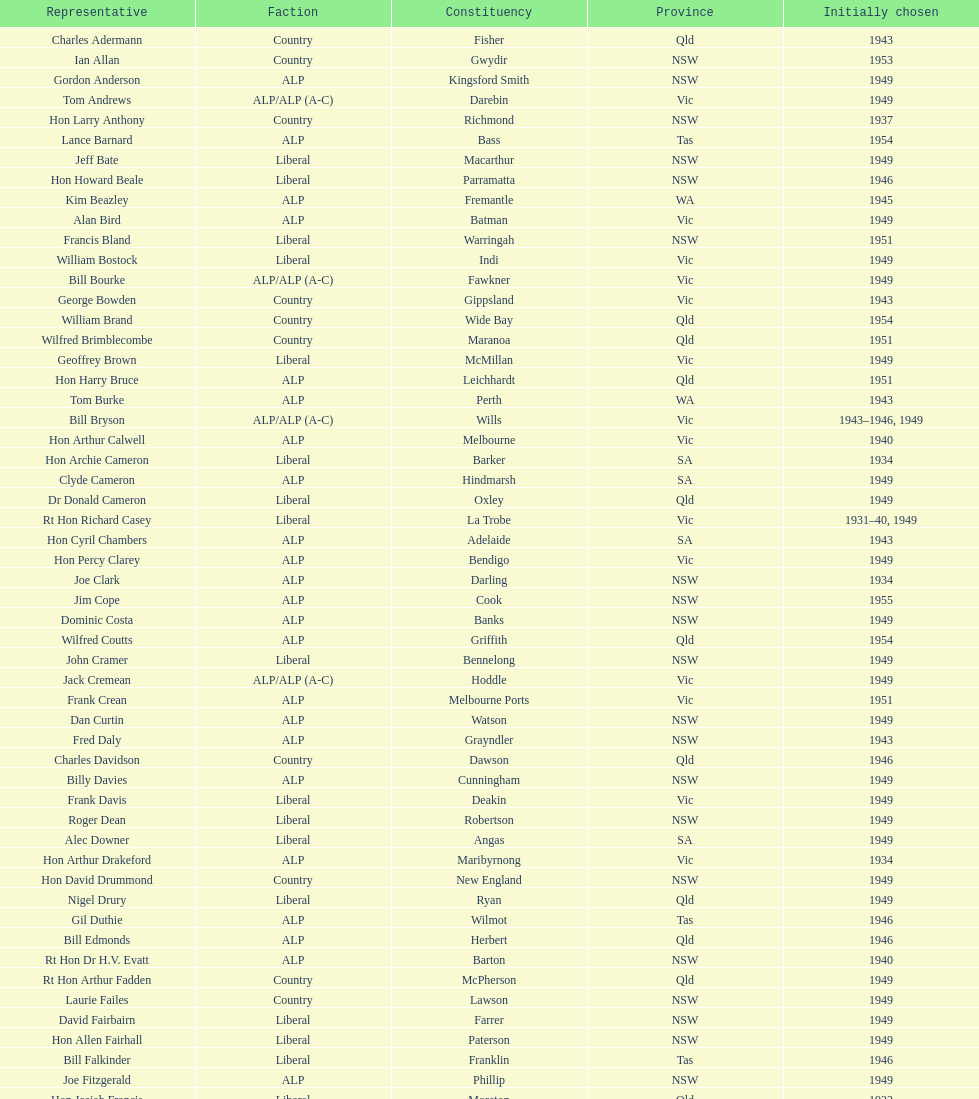What is the number of alp party members elected? 57. 